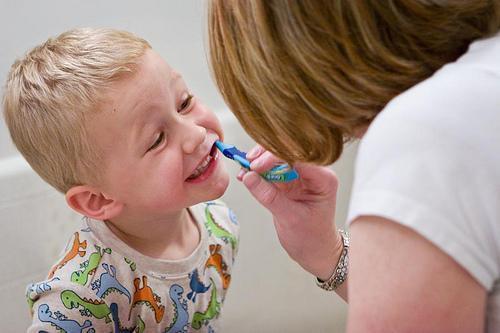How many people are there?
Give a very brief answer. 2. How many horses are there?
Give a very brief answer. 0. 